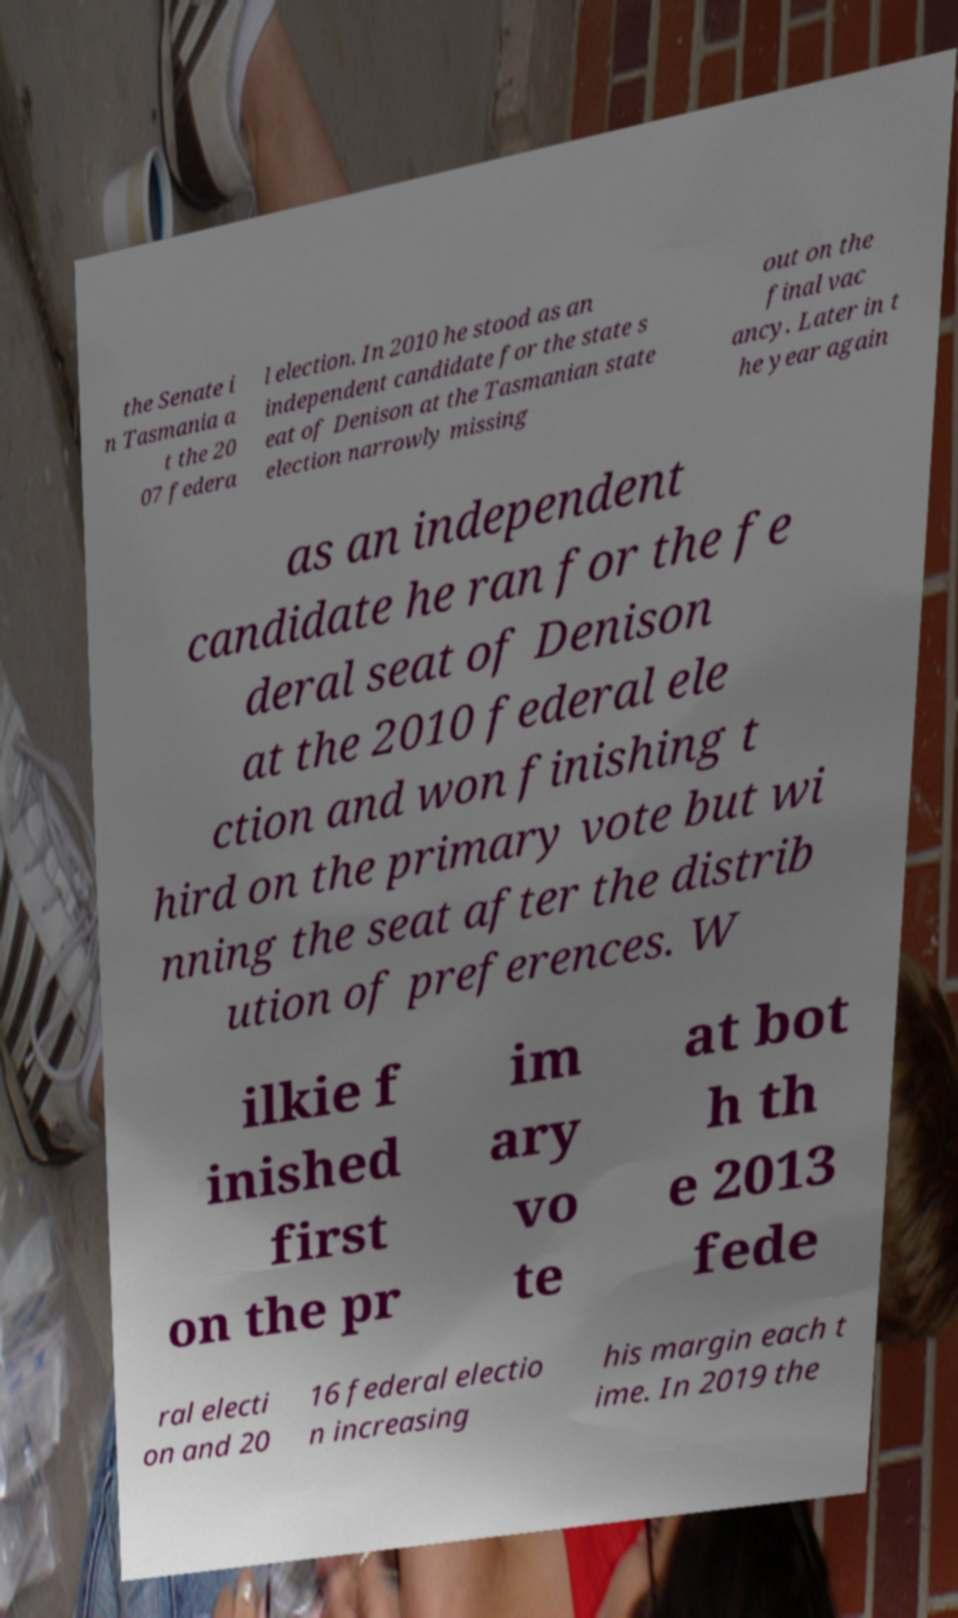Please identify and transcribe the text found in this image. the Senate i n Tasmania a t the 20 07 federa l election. In 2010 he stood as an independent candidate for the state s eat of Denison at the Tasmanian state election narrowly missing out on the final vac ancy. Later in t he year again as an independent candidate he ran for the fe deral seat of Denison at the 2010 federal ele ction and won finishing t hird on the primary vote but wi nning the seat after the distrib ution of preferences. W ilkie f inished first on the pr im ary vo te at bot h th e 2013 fede ral electi on and 20 16 federal electio n increasing his margin each t ime. In 2019 the 